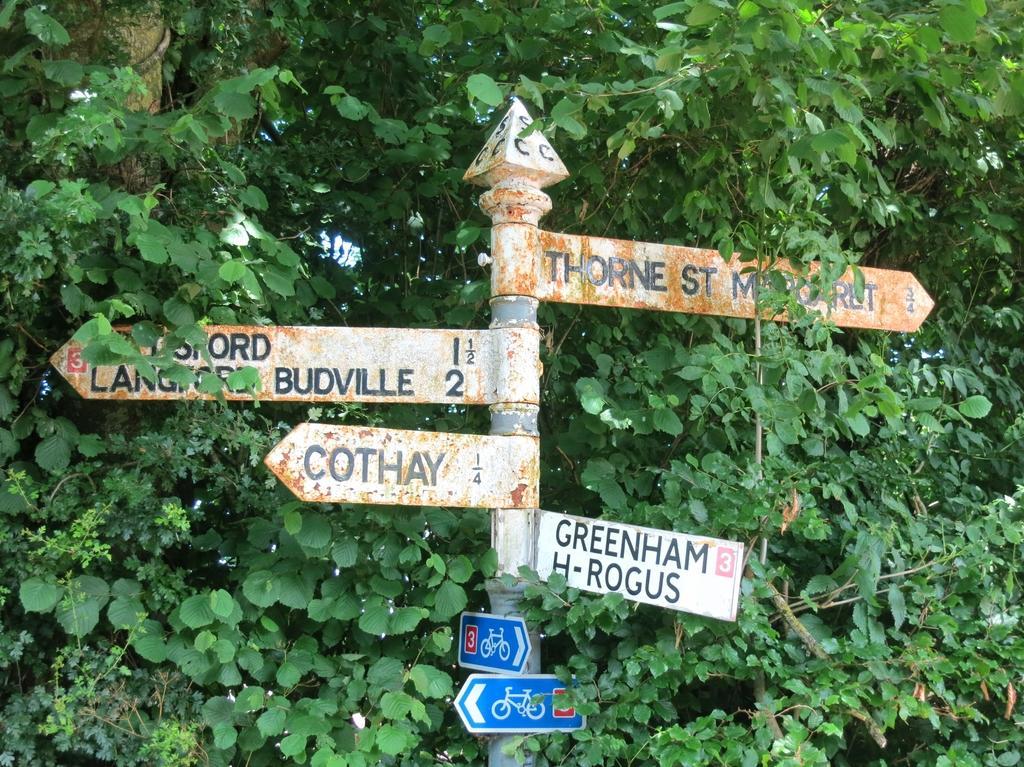Can you describe this image briefly? In this image, in the middle, we can see a metal pole and hoardings. In the background, we can see some trees and plants. 